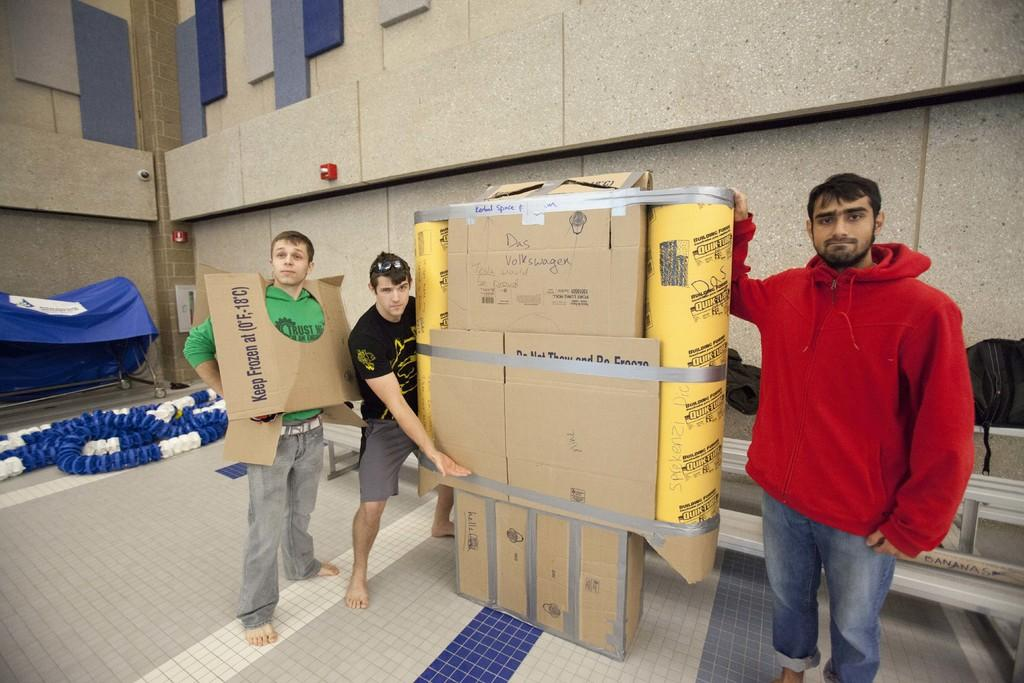<image>
Describe the image concisely. A man wearing a green shirt is wearing a piece of cardboard that says "Keep Frozen" 